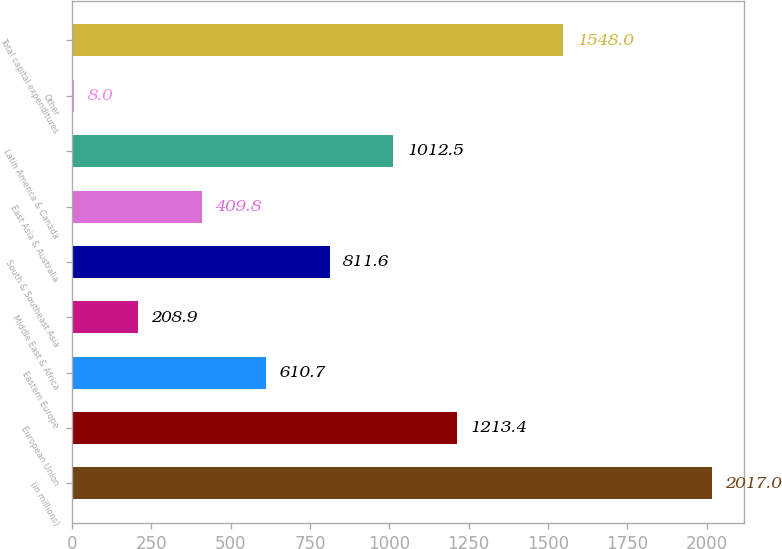Convert chart to OTSL. <chart><loc_0><loc_0><loc_500><loc_500><bar_chart><fcel>(in millions)<fcel>European Union<fcel>Eastern Europe<fcel>Middle East & Africa<fcel>South & Southeast Asia<fcel>East Asia & Australia<fcel>Latin America & Canada<fcel>Other<fcel>Total capital expenditures<nl><fcel>2017<fcel>1213.4<fcel>610.7<fcel>208.9<fcel>811.6<fcel>409.8<fcel>1012.5<fcel>8<fcel>1548<nl></chart> 